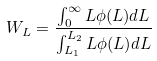Convert formula to latex. <formula><loc_0><loc_0><loc_500><loc_500>W _ { L } = { \frac { \int _ { 0 } ^ { \infty } L \phi ( L ) d L } { \int _ { L _ { 1 } } ^ { L _ { 2 } } L \phi ( L ) d L } }</formula> 